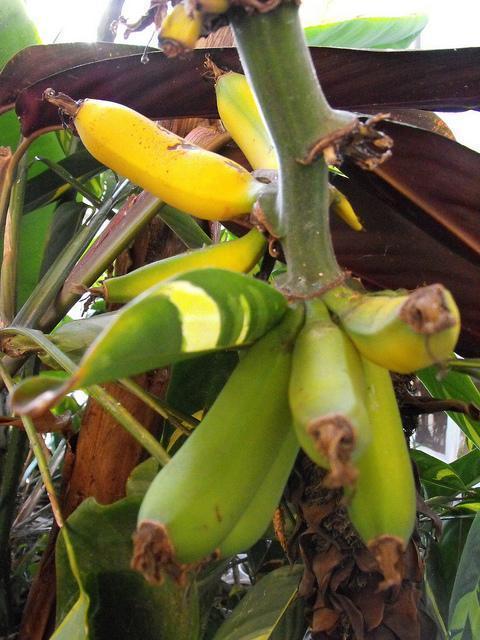How many bananas are there?
Give a very brief answer. 7. How many people are wearing sunglasses?
Give a very brief answer. 0. 